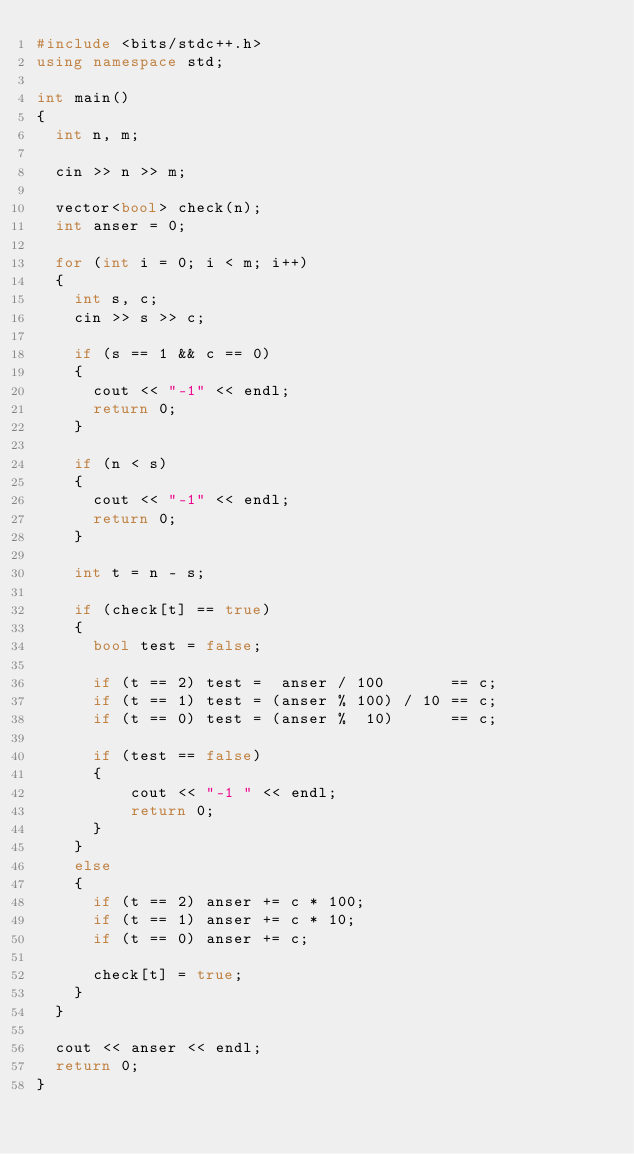Convert code to text. <code><loc_0><loc_0><loc_500><loc_500><_C++_>#include <bits/stdc++.h>
using namespace std;

int main()
{
  int n, m;
  
  cin >> n >> m;
  
  vector<bool> check(n);
  int anser = 0;
  
  for (int i = 0; i < m; i++)
  {
    int s, c;
    cin >> s >> c;
    
    if (s == 1 && c == 0)
    {
    	cout << "-1" << endl;
    	return 0;
    }
    
    if (n < s)
    {
    	cout << "-1" << endl;
    	return 0;
    }
    
    int t = n - s;
    
    if (check[t] == true)
    {
      bool test = false;
      
      if (t == 2) test =  anser / 100       == c;
      if (t == 1) test = (anser % 100) / 10 == c;
      if (t == 0) test = (anser %  10)      == c;
      
      if (test == false)
      {
          cout << "-1 " << endl;
          return 0;
      }
    }
    else
    {
      if (t == 2) anser += c * 100;
      if (t == 1) anser += c * 10;
      if (t == 0) anser += c;
      
      check[t] = true;
    }
  }
  
  cout << anser << endl;
  return 0;
}</code> 